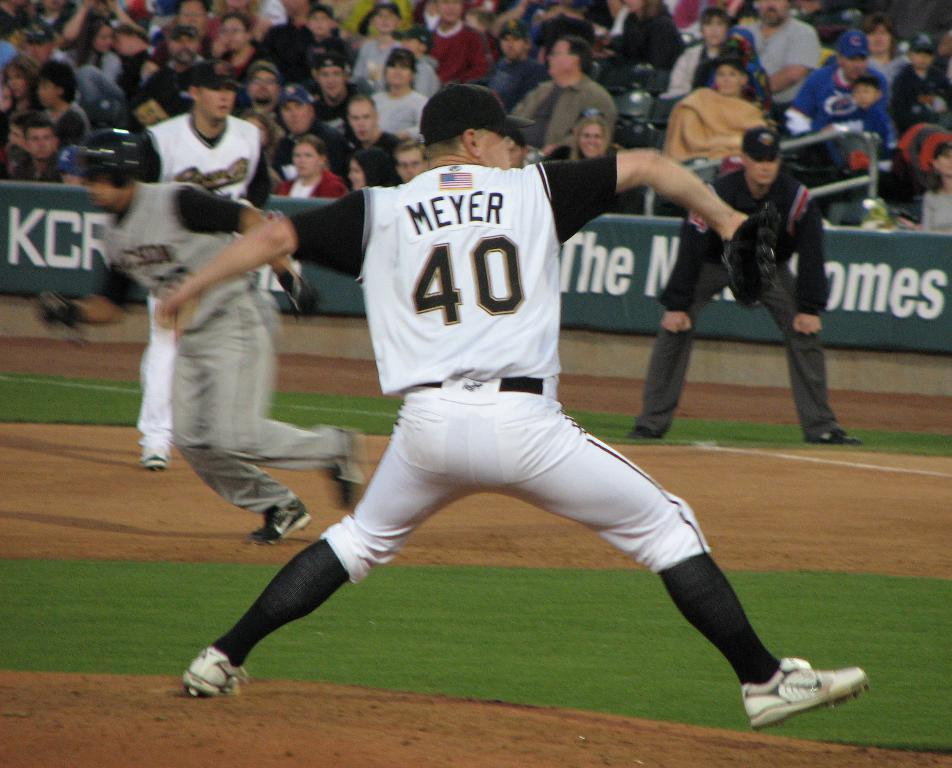<image>
Provide a brief description of the given image. Player number 40 whose name is Meyer is throwing the ball. 